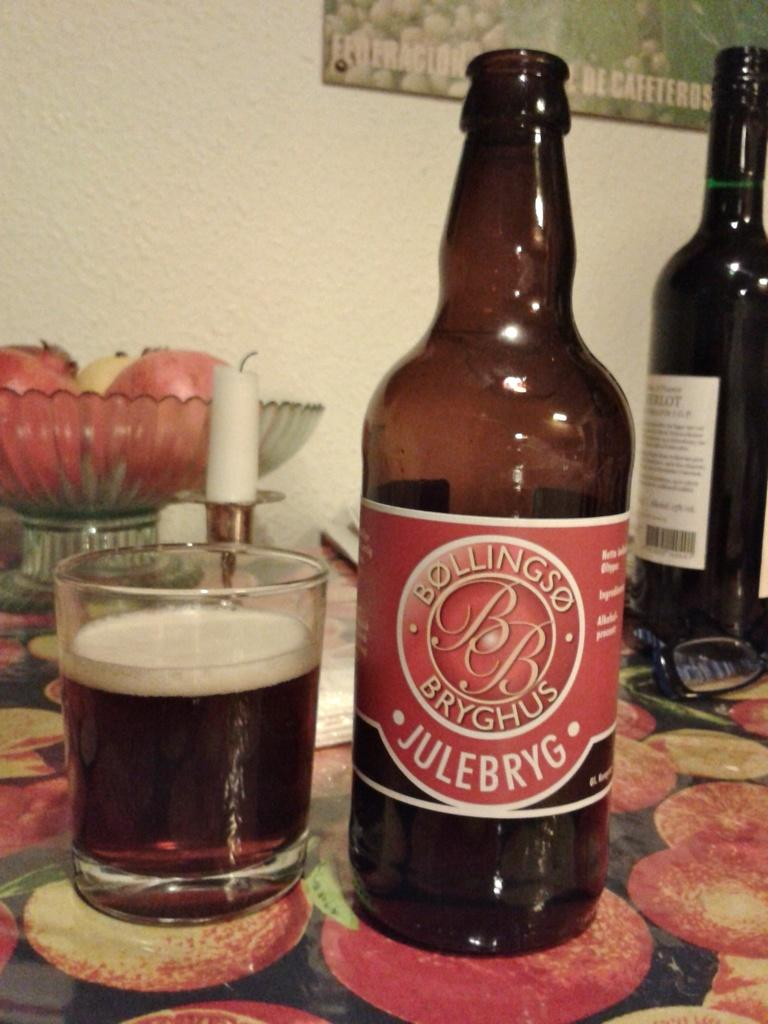<image>
Provide a brief description of the given image. A bottle of Bollingso Bryghus Julebryg sits next to a glass of the drink. 